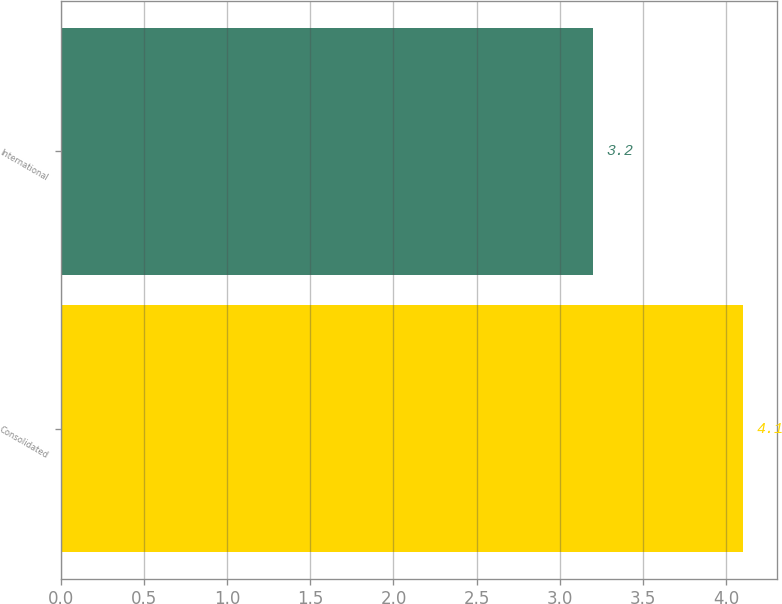Convert chart. <chart><loc_0><loc_0><loc_500><loc_500><bar_chart><fcel>Consolidated<fcel>International<nl><fcel>4.1<fcel>3.2<nl></chart> 